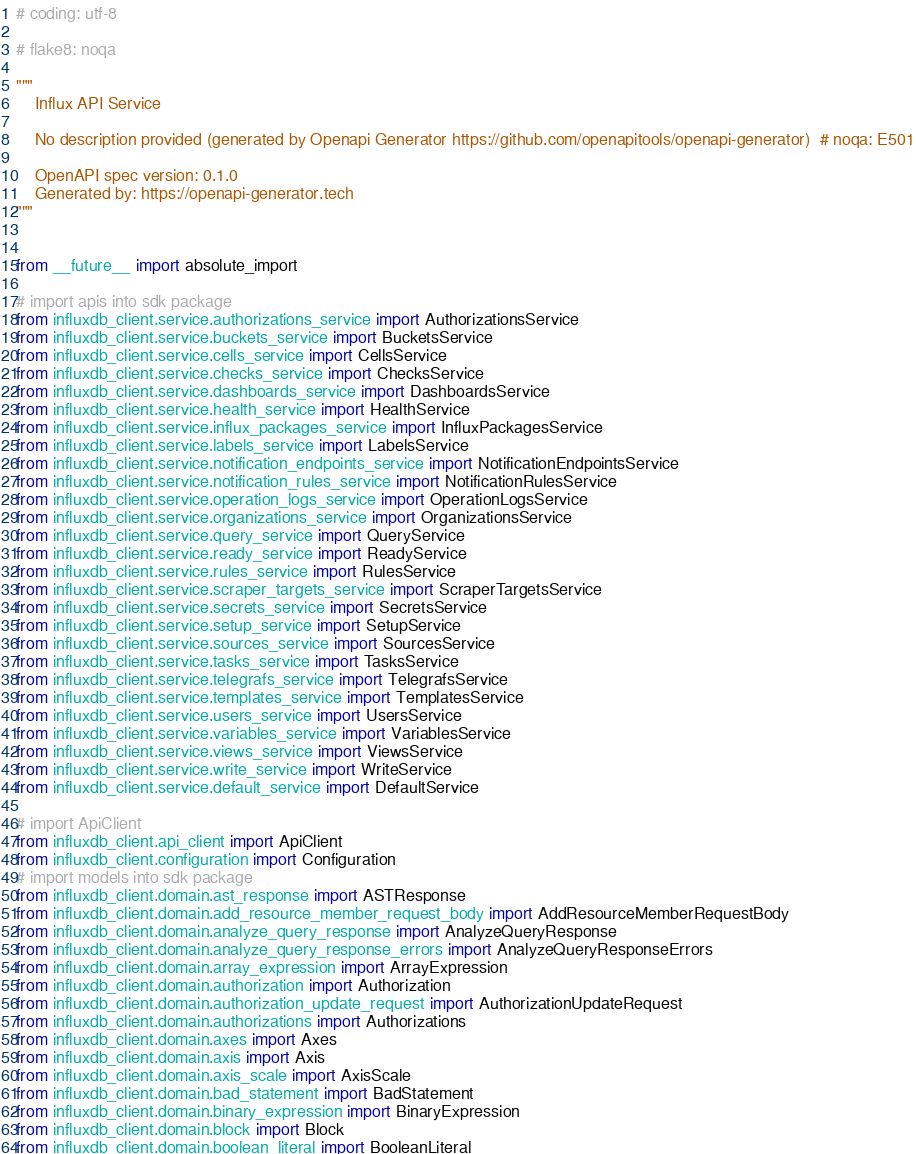<code> <loc_0><loc_0><loc_500><loc_500><_Python_># coding: utf-8

# flake8: noqa

"""
    Influx API Service

    No description provided (generated by Openapi Generator https://github.com/openapitools/openapi-generator)  # noqa: E501

    OpenAPI spec version: 0.1.0
    Generated by: https://openapi-generator.tech
"""


from __future__ import absolute_import

# import apis into sdk package
from influxdb_client.service.authorizations_service import AuthorizationsService
from influxdb_client.service.buckets_service import BucketsService
from influxdb_client.service.cells_service import CellsService
from influxdb_client.service.checks_service import ChecksService
from influxdb_client.service.dashboards_service import DashboardsService
from influxdb_client.service.health_service import HealthService
from influxdb_client.service.influx_packages_service import InfluxPackagesService
from influxdb_client.service.labels_service import LabelsService
from influxdb_client.service.notification_endpoints_service import NotificationEndpointsService
from influxdb_client.service.notification_rules_service import NotificationRulesService
from influxdb_client.service.operation_logs_service import OperationLogsService
from influxdb_client.service.organizations_service import OrganizationsService
from influxdb_client.service.query_service import QueryService
from influxdb_client.service.ready_service import ReadyService
from influxdb_client.service.rules_service import RulesService
from influxdb_client.service.scraper_targets_service import ScraperTargetsService
from influxdb_client.service.secrets_service import SecretsService
from influxdb_client.service.setup_service import SetupService
from influxdb_client.service.sources_service import SourcesService
from influxdb_client.service.tasks_service import TasksService
from influxdb_client.service.telegrafs_service import TelegrafsService
from influxdb_client.service.templates_service import TemplatesService
from influxdb_client.service.users_service import UsersService
from influxdb_client.service.variables_service import VariablesService
from influxdb_client.service.views_service import ViewsService
from influxdb_client.service.write_service import WriteService
from influxdb_client.service.default_service import DefaultService

# import ApiClient
from influxdb_client.api_client import ApiClient
from influxdb_client.configuration import Configuration
# import models into sdk package
from influxdb_client.domain.ast_response import ASTResponse
from influxdb_client.domain.add_resource_member_request_body import AddResourceMemberRequestBody
from influxdb_client.domain.analyze_query_response import AnalyzeQueryResponse
from influxdb_client.domain.analyze_query_response_errors import AnalyzeQueryResponseErrors
from influxdb_client.domain.array_expression import ArrayExpression
from influxdb_client.domain.authorization import Authorization
from influxdb_client.domain.authorization_update_request import AuthorizationUpdateRequest
from influxdb_client.domain.authorizations import Authorizations
from influxdb_client.domain.axes import Axes
from influxdb_client.domain.axis import Axis
from influxdb_client.domain.axis_scale import AxisScale
from influxdb_client.domain.bad_statement import BadStatement
from influxdb_client.domain.binary_expression import BinaryExpression
from influxdb_client.domain.block import Block
from influxdb_client.domain.boolean_literal import BooleanLiteral</code> 